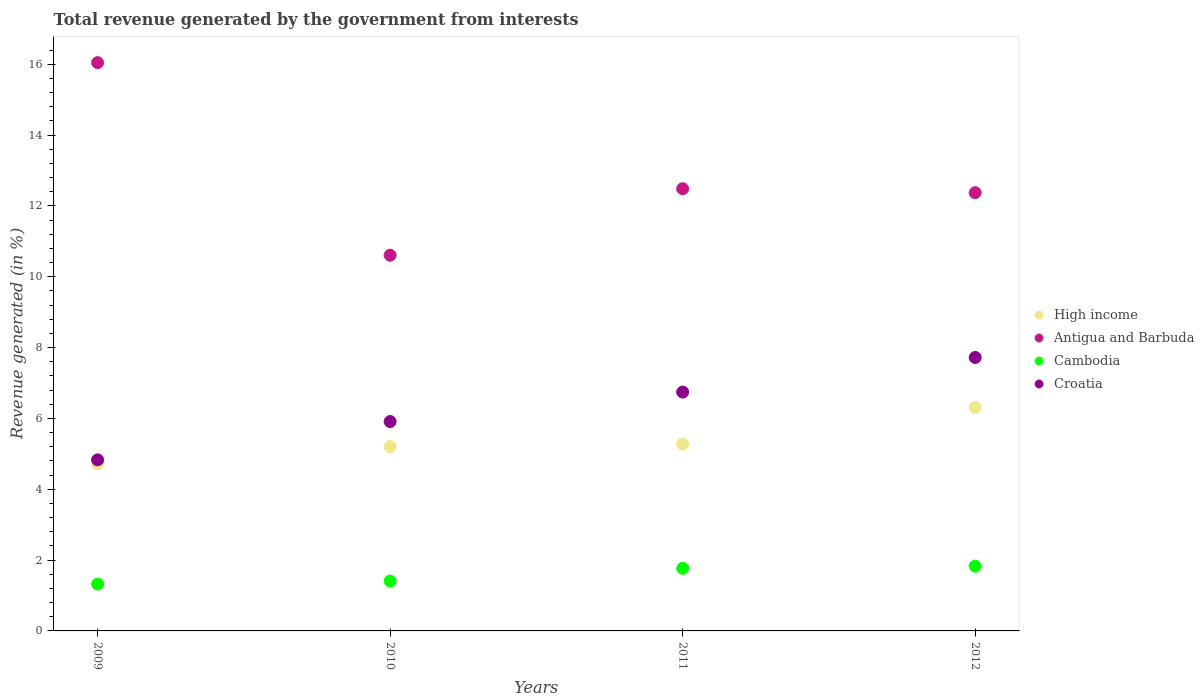What is the total revenue generated in Antigua and Barbuda in 2011?
Keep it short and to the point. 12.48. Across all years, what is the maximum total revenue generated in High income?
Offer a terse response. 6.31. Across all years, what is the minimum total revenue generated in Cambodia?
Give a very brief answer. 1.32. What is the total total revenue generated in Cambodia in the graph?
Keep it short and to the point. 6.32. What is the difference between the total revenue generated in Cambodia in 2009 and that in 2011?
Keep it short and to the point. -0.45. What is the difference between the total revenue generated in Antigua and Barbuda in 2010 and the total revenue generated in High income in 2009?
Offer a very short reply. 5.89. What is the average total revenue generated in Antigua and Barbuda per year?
Provide a succinct answer. 12.88. In the year 2010, what is the difference between the total revenue generated in High income and total revenue generated in Croatia?
Offer a terse response. -0.71. In how many years, is the total revenue generated in Croatia greater than 10 %?
Provide a succinct answer. 0. What is the ratio of the total revenue generated in Antigua and Barbuda in 2009 to that in 2010?
Your answer should be compact. 1.51. Is the total revenue generated in Cambodia in 2010 less than that in 2011?
Your response must be concise. Yes. What is the difference between the highest and the second highest total revenue generated in Antigua and Barbuda?
Offer a very short reply. 3.56. What is the difference between the highest and the lowest total revenue generated in High income?
Provide a short and direct response. 1.59. Is the total revenue generated in High income strictly greater than the total revenue generated in Croatia over the years?
Offer a very short reply. No. Is the total revenue generated in Antigua and Barbuda strictly less than the total revenue generated in Cambodia over the years?
Give a very brief answer. No. How many years are there in the graph?
Ensure brevity in your answer.  4. What is the difference between two consecutive major ticks on the Y-axis?
Keep it short and to the point. 2. Are the values on the major ticks of Y-axis written in scientific E-notation?
Ensure brevity in your answer.  No. Does the graph contain any zero values?
Keep it short and to the point. No. How many legend labels are there?
Make the answer very short. 4. How are the legend labels stacked?
Provide a succinct answer. Vertical. What is the title of the graph?
Make the answer very short. Total revenue generated by the government from interests. What is the label or title of the X-axis?
Your answer should be compact. Years. What is the label or title of the Y-axis?
Your answer should be very brief. Revenue generated (in %). What is the Revenue generated (in %) in High income in 2009?
Offer a terse response. 4.71. What is the Revenue generated (in %) in Antigua and Barbuda in 2009?
Your response must be concise. 16.04. What is the Revenue generated (in %) of Cambodia in 2009?
Offer a terse response. 1.32. What is the Revenue generated (in %) of Croatia in 2009?
Keep it short and to the point. 4.83. What is the Revenue generated (in %) of High income in 2010?
Provide a succinct answer. 5.2. What is the Revenue generated (in %) in Antigua and Barbuda in 2010?
Your answer should be compact. 10.61. What is the Revenue generated (in %) in Cambodia in 2010?
Provide a succinct answer. 1.41. What is the Revenue generated (in %) of Croatia in 2010?
Give a very brief answer. 5.91. What is the Revenue generated (in %) of High income in 2011?
Your answer should be compact. 5.28. What is the Revenue generated (in %) in Antigua and Barbuda in 2011?
Your answer should be very brief. 12.48. What is the Revenue generated (in %) of Cambodia in 2011?
Provide a short and direct response. 1.77. What is the Revenue generated (in %) in Croatia in 2011?
Offer a very short reply. 6.74. What is the Revenue generated (in %) of High income in 2012?
Ensure brevity in your answer.  6.31. What is the Revenue generated (in %) of Antigua and Barbuda in 2012?
Offer a very short reply. 12.37. What is the Revenue generated (in %) in Cambodia in 2012?
Your answer should be compact. 1.83. What is the Revenue generated (in %) of Croatia in 2012?
Make the answer very short. 7.72. Across all years, what is the maximum Revenue generated (in %) of High income?
Provide a short and direct response. 6.31. Across all years, what is the maximum Revenue generated (in %) of Antigua and Barbuda?
Your answer should be compact. 16.04. Across all years, what is the maximum Revenue generated (in %) of Cambodia?
Your response must be concise. 1.83. Across all years, what is the maximum Revenue generated (in %) of Croatia?
Offer a very short reply. 7.72. Across all years, what is the minimum Revenue generated (in %) in High income?
Keep it short and to the point. 4.71. Across all years, what is the minimum Revenue generated (in %) in Antigua and Barbuda?
Your answer should be very brief. 10.61. Across all years, what is the minimum Revenue generated (in %) of Cambodia?
Keep it short and to the point. 1.32. Across all years, what is the minimum Revenue generated (in %) in Croatia?
Give a very brief answer. 4.83. What is the total Revenue generated (in %) in High income in the graph?
Make the answer very short. 21.5. What is the total Revenue generated (in %) in Antigua and Barbuda in the graph?
Offer a very short reply. 51.51. What is the total Revenue generated (in %) in Cambodia in the graph?
Give a very brief answer. 6.32. What is the total Revenue generated (in %) of Croatia in the graph?
Offer a terse response. 25.2. What is the difference between the Revenue generated (in %) in High income in 2009 and that in 2010?
Offer a very short reply. -0.49. What is the difference between the Revenue generated (in %) of Antigua and Barbuda in 2009 and that in 2010?
Provide a succinct answer. 5.44. What is the difference between the Revenue generated (in %) of Cambodia in 2009 and that in 2010?
Offer a terse response. -0.09. What is the difference between the Revenue generated (in %) of Croatia in 2009 and that in 2010?
Offer a terse response. -1.08. What is the difference between the Revenue generated (in %) in High income in 2009 and that in 2011?
Offer a very short reply. -0.56. What is the difference between the Revenue generated (in %) of Antigua and Barbuda in 2009 and that in 2011?
Provide a short and direct response. 3.56. What is the difference between the Revenue generated (in %) in Cambodia in 2009 and that in 2011?
Give a very brief answer. -0.45. What is the difference between the Revenue generated (in %) of Croatia in 2009 and that in 2011?
Offer a terse response. -1.91. What is the difference between the Revenue generated (in %) in High income in 2009 and that in 2012?
Your response must be concise. -1.59. What is the difference between the Revenue generated (in %) of Antigua and Barbuda in 2009 and that in 2012?
Keep it short and to the point. 3.67. What is the difference between the Revenue generated (in %) of Cambodia in 2009 and that in 2012?
Your response must be concise. -0.51. What is the difference between the Revenue generated (in %) in Croatia in 2009 and that in 2012?
Make the answer very short. -2.89. What is the difference between the Revenue generated (in %) in High income in 2010 and that in 2011?
Your answer should be very brief. -0.07. What is the difference between the Revenue generated (in %) in Antigua and Barbuda in 2010 and that in 2011?
Offer a terse response. -1.88. What is the difference between the Revenue generated (in %) in Cambodia in 2010 and that in 2011?
Keep it short and to the point. -0.36. What is the difference between the Revenue generated (in %) of Croatia in 2010 and that in 2011?
Ensure brevity in your answer.  -0.83. What is the difference between the Revenue generated (in %) of High income in 2010 and that in 2012?
Ensure brevity in your answer.  -1.1. What is the difference between the Revenue generated (in %) of Antigua and Barbuda in 2010 and that in 2012?
Offer a very short reply. -1.77. What is the difference between the Revenue generated (in %) of Cambodia in 2010 and that in 2012?
Provide a short and direct response. -0.42. What is the difference between the Revenue generated (in %) in Croatia in 2010 and that in 2012?
Ensure brevity in your answer.  -1.81. What is the difference between the Revenue generated (in %) of High income in 2011 and that in 2012?
Ensure brevity in your answer.  -1.03. What is the difference between the Revenue generated (in %) in Antigua and Barbuda in 2011 and that in 2012?
Ensure brevity in your answer.  0.11. What is the difference between the Revenue generated (in %) in Cambodia in 2011 and that in 2012?
Your answer should be very brief. -0.06. What is the difference between the Revenue generated (in %) in Croatia in 2011 and that in 2012?
Your response must be concise. -0.98. What is the difference between the Revenue generated (in %) in High income in 2009 and the Revenue generated (in %) in Antigua and Barbuda in 2010?
Offer a very short reply. -5.89. What is the difference between the Revenue generated (in %) of High income in 2009 and the Revenue generated (in %) of Cambodia in 2010?
Give a very brief answer. 3.31. What is the difference between the Revenue generated (in %) of High income in 2009 and the Revenue generated (in %) of Croatia in 2010?
Make the answer very short. -1.2. What is the difference between the Revenue generated (in %) in Antigua and Barbuda in 2009 and the Revenue generated (in %) in Cambodia in 2010?
Provide a succinct answer. 14.64. What is the difference between the Revenue generated (in %) of Antigua and Barbuda in 2009 and the Revenue generated (in %) of Croatia in 2010?
Provide a short and direct response. 10.13. What is the difference between the Revenue generated (in %) of Cambodia in 2009 and the Revenue generated (in %) of Croatia in 2010?
Offer a terse response. -4.59. What is the difference between the Revenue generated (in %) of High income in 2009 and the Revenue generated (in %) of Antigua and Barbuda in 2011?
Make the answer very short. -7.77. What is the difference between the Revenue generated (in %) in High income in 2009 and the Revenue generated (in %) in Cambodia in 2011?
Offer a very short reply. 2.95. What is the difference between the Revenue generated (in %) in High income in 2009 and the Revenue generated (in %) in Croatia in 2011?
Give a very brief answer. -2.03. What is the difference between the Revenue generated (in %) in Antigua and Barbuda in 2009 and the Revenue generated (in %) in Cambodia in 2011?
Provide a succinct answer. 14.27. What is the difference between the Revenue generated (in %) of Cambodia in 2009 and the Revenue generated (in %) of Croatia in 2011?
Make the answer very short. -5.42. What is the difference between the Revenue generated (in %) of High income in 2009 and the Revenue generated (in %) of Antigua and Barbuda in 2012?
Your answer should be very brief. -7.66. What is the difference between the Revenue generated (in %) of High income in 2009 and the Revenue generated (in %) of Cambodia in 2012?
Your answer should be very brief. 2.89. What is the difference between the Revenue generated (in %) of High income in 2009 and the Revenue generated (in %) of Croatia in 2012?
Your response must be concise. -3. What is the difference between the Revenue generated (in %) in Antigua and Barbuda in 2009 and the Revenue generated (in %) in Cambodia in 2012?
Provide a succinct answer. 14.22. What is the difference between the Revenue generated (in %) in Antigua and Barbuda in 2009 and the Revenue generated (in %) in Croatia in 2012?
Ensure brevity in your answer.  8.32. What is the difference between the Revenue generated (in %) of Cambodia in 2009 and the Revenue generated (in %) of Croatia in 2012?
Provide a short and direct response. -6.4. What is the difference between the Revenue generated (in %) in High income in 2010 and the Revenue generated (in %) in Antigua and Barbuda in 2011?
Offer a very short reply. -7.28. What is the difference between the Revenue generated (in %) of High income in 2010 and the Revenue generated (in %) of Cambodia in 2011?
Your response must be concise. 3.44. What is the difference between the Revenue generated (in %) of High income in 2010 and the Revenue generated (in %) of Croatia in 2011?
Provide a succinct answer. -1.54. What is the difference between the Revenue generated (in %) in Antigua and Barbuda in 2010 and the Revenue generated (in %) in Cambodia in 2011?
Your answer should be very brief. 8.84. What is the difference between the Revenue generated (in %) of Antigua and Barbuda in 2010 and the Revenue generated (in %) of Croatia in 2011?
Offer a terse response. 3.86. What is the difference between the Revenue generated (in %) of Cambodia in 2010 and the Revenue generated (in %) of Croatia in 2011?
Give a very brief answer. -5.34. What is the difference between the Revenue generated (in %) in High income in 2010 and the Revenue generated (in %) in Antigua and Barbuda in 2012?
Your answer should be very brief. -7.17. What is the difference between the Revenue generated (in %) in High income in 2010 and the Revenue generated (in %) in Cambodia in 2012?
Make the answer very short. 3.38. What is the difference between the Revenue generated (in %) of High income in 2010 and the Revenue generated (in %) of Croatia in 2012?
Your response must be concise. -2.52. What is the difference between the Revenue generated (in %) in Antigua and Barbuda in 2010 and the Revenue generated (in %) in Cambodia in 2012?
Your answer should be very brief. 8.78. What is the difference between the Revenue generated (in %) in Antigua and Barbuda in 2010 and the Revenue generated (in %) in Croatia in 2012?
Provide a succinct answer. 2.89. What is the difference between the Revenue generated (in %) in Cambodia in 2010 and the Revenue generated (in %) in Croatia in 2012?
Give a very brief answer. -6.31. What is the difference between the Revenue generated (in %) in High income in 2011 and the Revenue generated (in %) in Antigua and Barbuda in 2012?
Give a very brief answer. -7.1. What is the difference between the Revenue generated (in %) in High income in 2011 and the Revenue generated (in %) in Cambodia in 2012?
Ensure brevity in your answer.  3.45. What is the difference between the Revenue generated (in %) of High income in 2011 and the Revenue generated (in %) of Croatia in 2012?
Make the answer very short. -2.44. What is the difference between the Revenue generated (in %) of Antigua and Barbuda in 2011 and the Revenue generated (in %) of Cambodia in 2012?
Give a very brief answer. 10.66. What is the difference between the Revenue generated (in %) of Antigua and Barbuda in 2011 and the Revenue generated (in %) of Croatia in 2012?
Make the answer very short. 4.76. What is the difference between the Revenue generated (in %) in Cambodia in 2011 and the Revenue generated (in %) in Croatia in 2012?
Give a very brief answer. -5.95. What is the average Revenue generated (in %) of High income per year?
Your answer should be very brief. 5.38. What is the average Revenue generated (in %) of Antigua and Barbuda per year?
Keep it short and to the point. 12.88. What is the average Revenue generated (in %) of Cambodia per year?
Keep it short and to the point. 1.58. What is the average Revenue generated (in %) of Croatia per year?
Provide a short and direct response. 6.3. In the year 2009, what is the difference between the Revenue generated (in %) of High income and Revenue generated (in %) of Antigua and Barbuda?
Provide a succinct answer. -11.33. In the year 2009, what is the difference between the Revenue generated (in %) in High income and Revenue generated (in %) in Cambodia?
Your answer should be very brief. 3.39. In the year 2009, what is the difference between the Revenue generated (in %) of High income and Revenue generated (in %) of Croatia?
Offer a terse response. -0.11. In the year 2009, what is the difference between the Revenue generated (in %) of Antigua and Barbuda and Revenue generated (in %) of Cambodia?
Offer a terse response. 14.72. In the year 2009, what is the difference between the Revenue generated (in %) of Antigua and Barbuda and Revenue generated (in %) of Croatia?
Provide a succinct answer. 11.21. In the year 2009, what is the difference between the Revenue generated (in %) of Cambodia and Revenue generated (in %) of Croatia?
Give a very brief answer. -3.51. In the year 2010, what is the difference between the Revenue generated (in %) in High income and Revenue generated (in %) in Antigua and Barbuda?
Your answer should be very brief. -5.4. In the year 2010, what is the difference between the Revenue generated (in %) of High income and Revenue generated (in %) of Cambodia?
Give a very brief answer. 3.8. In the year 2010, what is the difference between the Revenue generated (in %) in High income and Revenue generated (in %) in Croatia?
Offer a very short reply. -0.71. In the year 2010, what is the difference between the Revenue generated (in %) of Antigua and Barbuda and Revenue generated (in %) of Cambodia?
Your answer should be compact. 9.2. In the year 2010, what is the difference between the Revenue generated (in %) in Antigua and Barbuda and Revenue generated (in %) in Croatia?
Make the answer very short. 4.69. In the year 2010, what is the difference between the Revenue generated (in %) of Cambodia and Revenue generated (in %) of Croatia?
Keep it short and to the point. -4.5. In the year 2011, what is the difference between the Revenue generated (in %) in High income and Revenue generated (in %) in Antigua and Barbuda?
Your response must be concise. -7.21. In the year 2011, what is the difference between the Revenue generated (in %) of High income and Revenue generated (in %) of Cambodia?
Give a very brief answer. 3.51. In the year 2011, what is the difference between the Revenue generated (in %) in High income and Revenue generated (in %) in Croatia?
Give a very brief answer. -1.47. In the year 2011, what is the difference between the Revenue generated (in %) of Antigua and Barbuda and Revenue generated (in %) of Cambodia?
Your answer should be very brief. 10.72. In the year 2011, what is the difference between the Revenue generated (in %) of Antigua and Barbuda and Revenue generated (in %) of Croatia?
Your answer should be very brief. 5.74. In the year 2011, what is the difference between the Revenue generated (in %) in Cambodia and Revenue generated (in %) in Croatia?
Offer a very short reply. -4.97. In the year 2012, what is the difference between the Revenue generated (in %) of High income and Revenue generated (in %) of Antigua and Barbuda?
Provide a short and direct response. -6.06. In the year 2012, what is the difference between the Revenue generated (in %) of High income and Revenue generated (in %) of Cambodia?
Keep it short and to the point. 4.48. In the year 2012, what is the difference between the Revenue generated (in %) of High income and Revenue generated (in %) of Croatia?
Your response must be concise. -1.41. In the year 2012, what is the difference between the Revenue generated (in %) in Antigua and Barbuda and Revenue generated (in %) in Cambodia?
Provide a short and direct response. 10.55. In the year 2012, what is the difference between the Revenue generated (in %) in Antigua and Barbuda and Revenue generated (in %) in Croatia?
Your response must be concise. 4.65. In the year 2012, what is the difference between the Revenue generated (in %) in Cambodia and Revenue generated (in %) in Croatia?
Offer a very short reply. -5.89. What is the ratio of the Revenue generated (in %) in High income in 2009 to that in 2010?
Keep it short and to the point. 0.91. What is the ratio of the Revenue generated (in %) in Antigua and Barbuda in 2009 to that in 2010?
Your response must be concise. 1.51. What is the ratio of the Revenue generated (in %) of Cambodia in 2009 to that in 2010?
Your answer should be compact. 0.94. What is the ratio of the Revenue generated (in %) in Croatia in 2009 to that in 2010?
Give a very brief answer. 0.82. What is the ratio of the Revenue generated (in %) of High income in 2009 to that in 2011?
Ensure brevity in your answer.  0.89. What is the ratio of the Revenue generated (in %) in Antigua and Barbuda in 2009 to that in 2011?
Your answer should be very brief. 1.29. What is the ratio of the Revenue generated (in %) in Cambodia in 2009 to that in 2011?
Your answer should be very brief. 0.75. What is the ratio of the Revenue generated (in %) of Croatia in 2009 to that in 2011?
Provide a succinct answer. 0.72. What is the ratio of the Revenue generated (in %) of High income in 2009 to that in 2012?
Your answer should be very brief. 0.75. What is the ratio of the Revenue generated (in %) of Antigua and Barbuda in 2009 to that in 2012?
Your response must be concise. 1.3. What is the ratio of the Revenue generated (in %) of Cambodia in 2009 to that in 2012?
Provide a short and direct response. 0.72. What is the ratio of the Revenue generated (in %) in Croatia in 2009 to that in 2012?
Keep it short and to the point. 0.63. What is the ratio of the Revenue generated (in %) in High income in 2010 to that in 2011?
Your response must be concise. 0.99. What is the ratio of the Revenue generated (in %) in Antigua and Barbuda in 2010 to that in 2011?
Give a very brief answer. 0.85. What is the ratio of the Revenue generated (in %) in Cambodia in 2010 to that in 2011?
Make the answer very short. 0.8. What is the ratio of the Revenue generated (in %) in Croatia in 2010 to that in 2011?
Your answer should be very brief. 0.88. What is the ratio of the Revenue generated (in %) of High income in 2010 to that in 2012?
Make the answer very short. 0.82. What is the ratio of the Revenue generated (in %) in Antigua and Barbuda in 2010 to that in 2012?
Give a very brief answer. 0.86. What is the ratio of the Revenue generated (in %) of Cambodia in 2010 to that in 2012?
Give a very brief answer. 0.77. What is the ratio of the Revenue generated (in %) in Croatia in 2010 to that in 2012?
Provide a short and direct response. 0.77. What is the ratio of the Revenue generated (in %) of High income in 2011 to that in 2012?
Provide a short and direct response. 0.84. What is the ratio of the Revenue generated (in %) in Cambodia in 2011 to that in 2012?
Your response must be concise. 0.97. What is the ratio of the Revenue generated (in %) of Croatia in 2011 to that in 2012?
Offer a very short reply. 0.87. What is the difference between the highest and the second highest Revenue generated (in %) of High income?
Your answer should be very brief. 1.03. What is the difference between the highest and the second highest Revenue generated (in %) of Antigua and Barbuda?
Your answer should be very brief. 3.56. What is the difference between the highest and the second highest Revenue generated (in %) of Cambodia?
Offer a terse response. 0.06. What is the difference between the highest and the second highest Revenue generated (in %) of Croatia?
Your response must be concise. 0.98. What is the difference between the highest and the lowest Revenue generated (in %) in High income?
Provide a succinct answer. 1.59. What is the difference between the highest and the lowest Revenue generated (in %) in Antigua and Barbuda?
Offer a very short reply. 5.44. What is the difference between the highest and the lowest Revenue generated (in %) of Cambodia?
Ensure brevity in your answer.  0.51. What is the difference between the highest and the lowest Revenue generated (in %) of Croatia?
Your response must be concise. 2.89. 